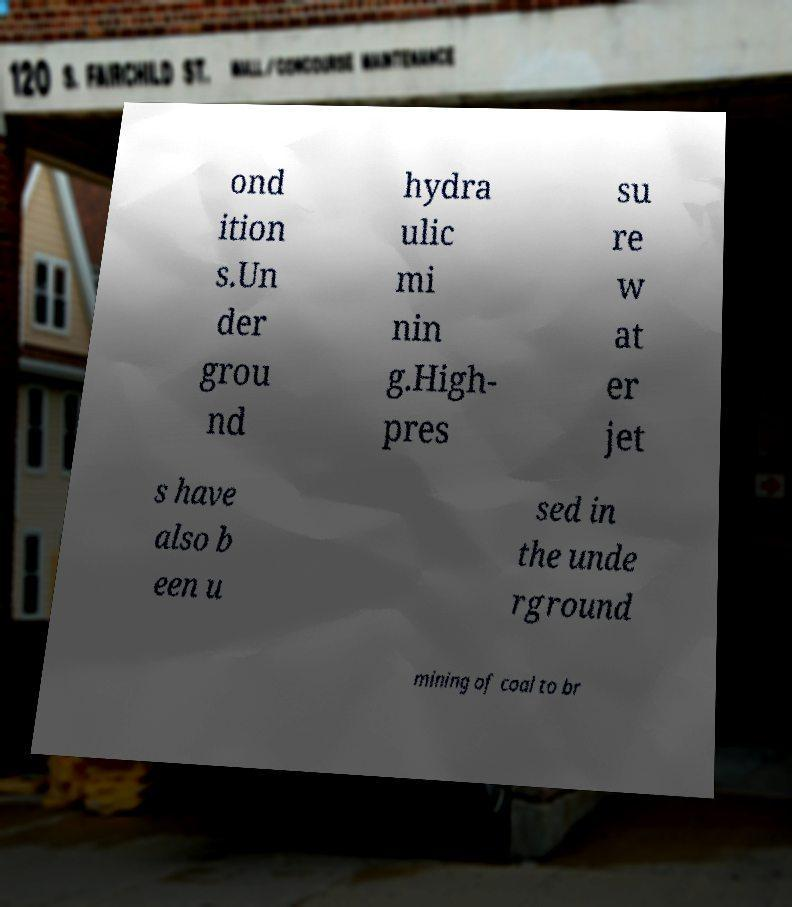What messages or text are displayed in this image? I need them in a readable, typed format. ond ition s.Un der grou nd hydra ulic mi nin g.High- pres su re w at er jet s have also b een u sed in the unde rground mining of coal to br 